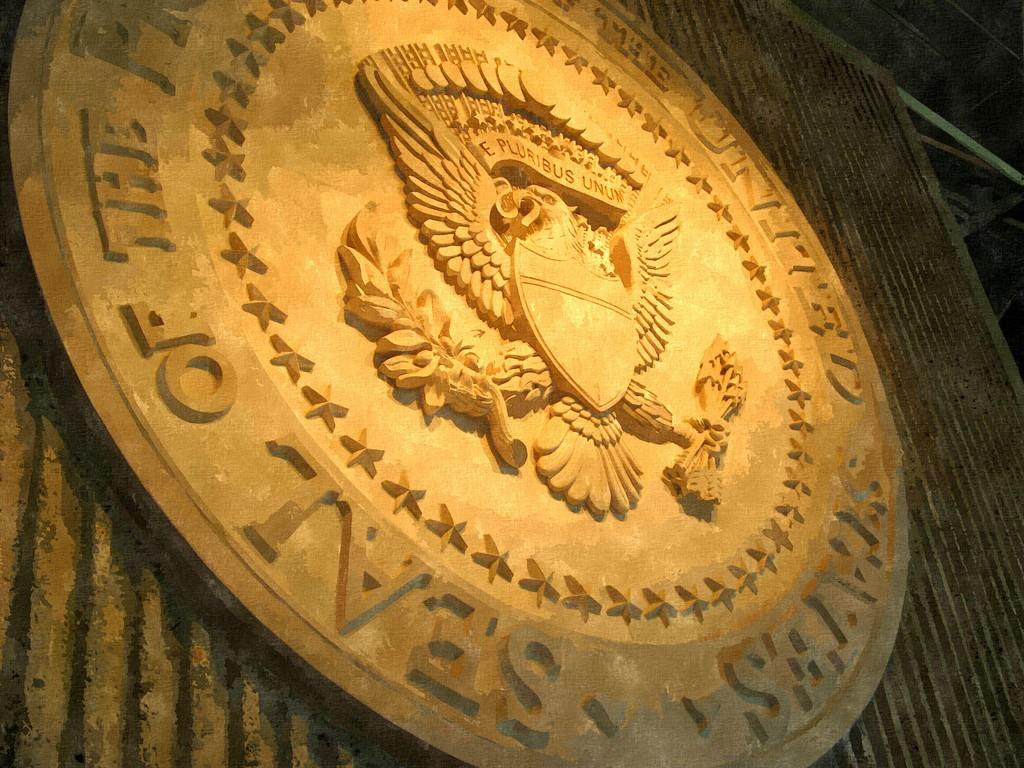<image>
Provide a brief description of the given image. A United States seal is engraved in stone on a wall. 